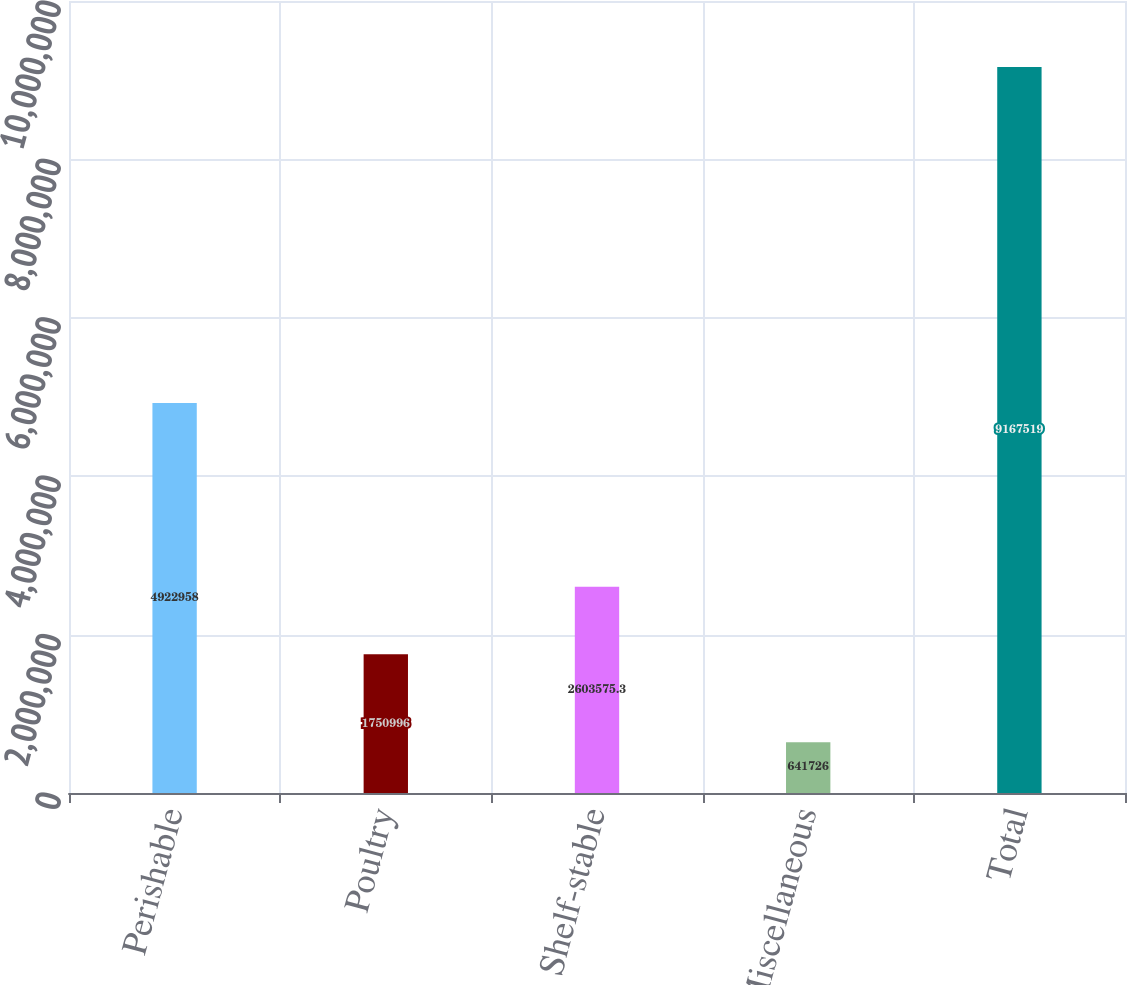Convert chart. <chart><loc_0><loc_0><loc_500><loc_500><bar_chart><fcel>Perishable<fcel>Poultry<fcel>Shelf-stable<fcel>Miscellaneous<fcel>Total<nl><fcel>4.92296e+06<fcel>1.751e+06<fcel>2.60358e+06<fcel>641726<fcel>9.16752e+06<nl></chart> 